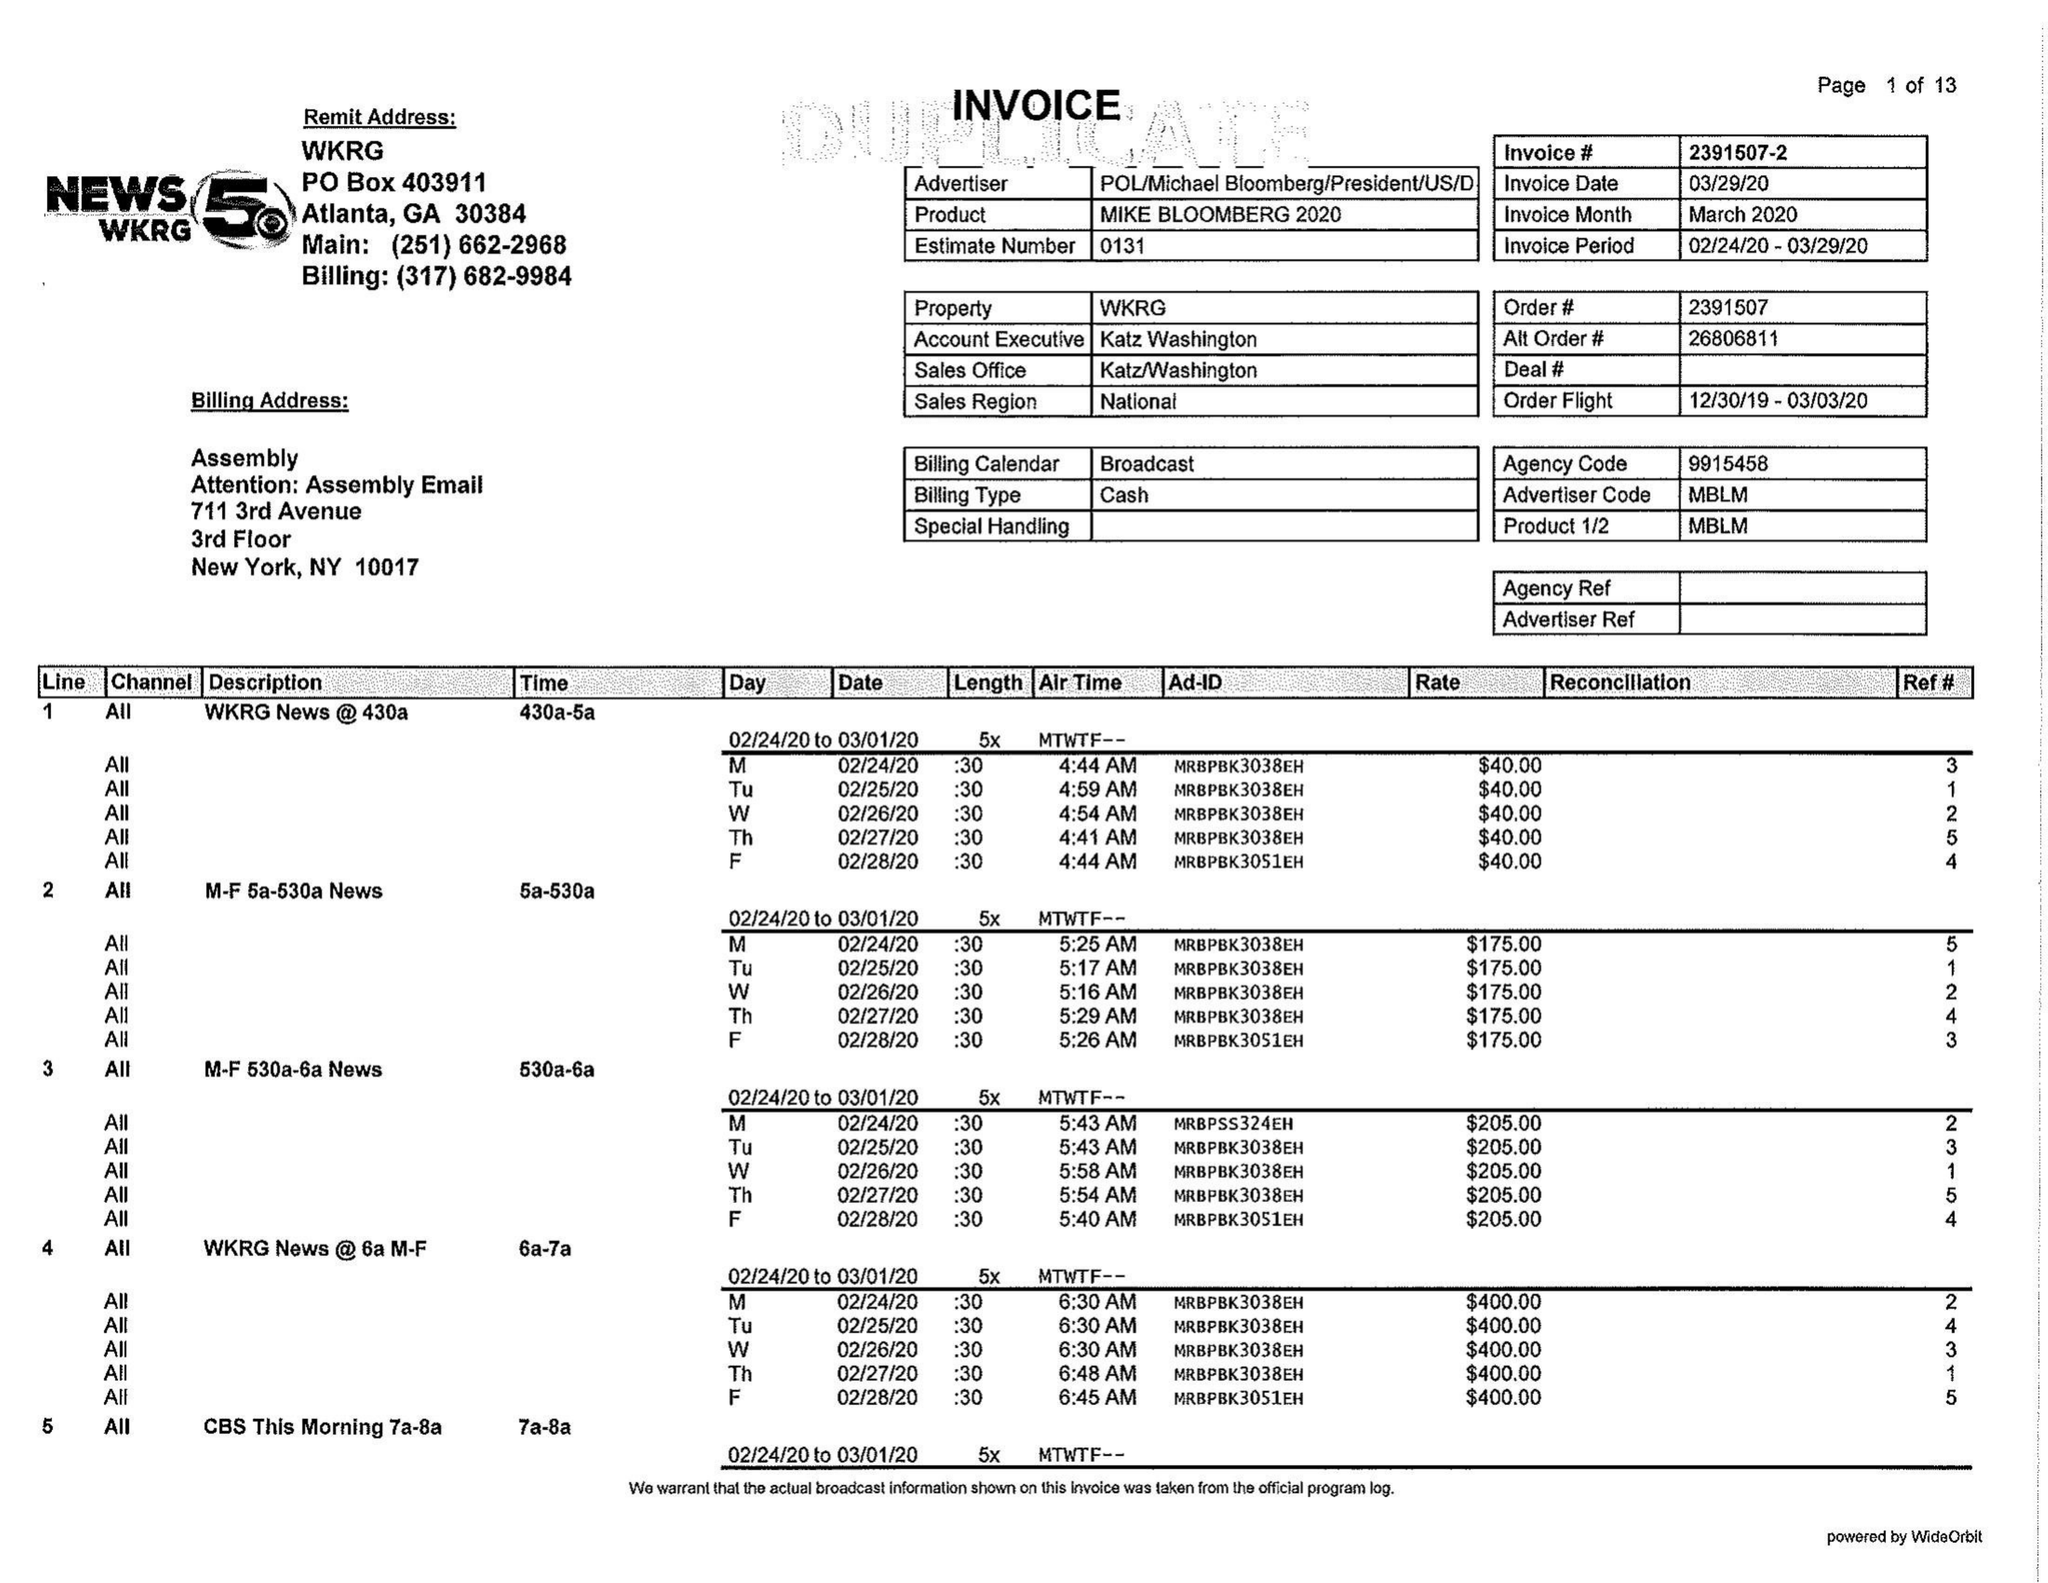What is the value for the contract_num?
Answer the question using a single word or phrase. 2391507 